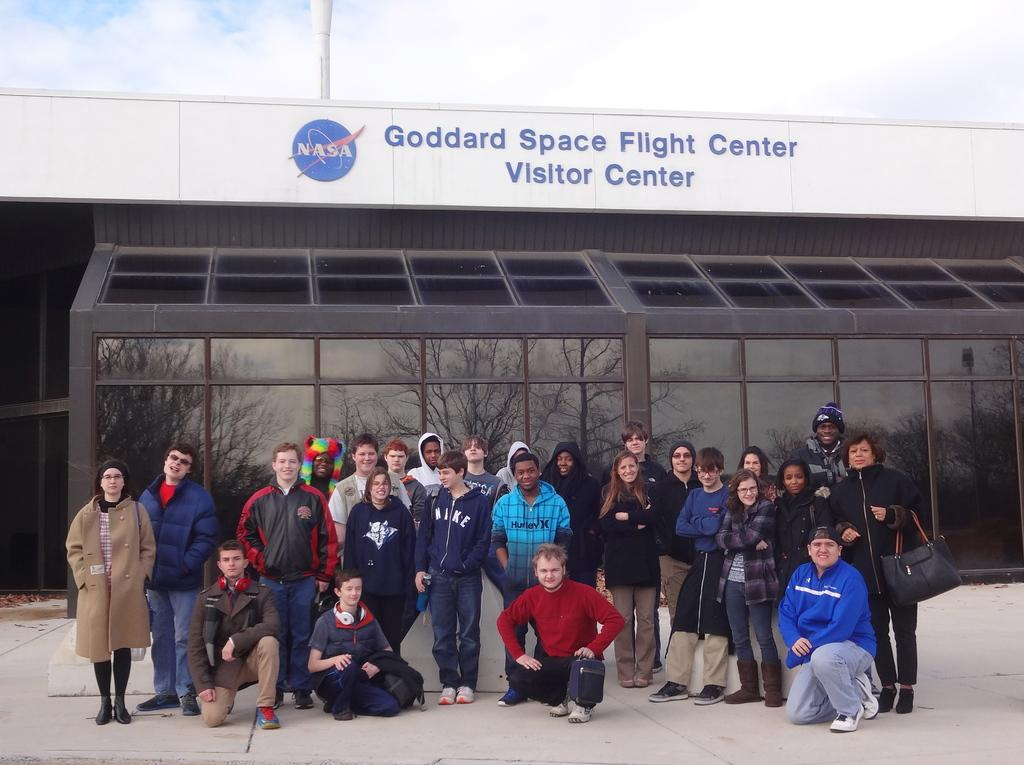What are the people in the image doing? The persons in the image are standing on the road. What can be seen in the background of the image? There are buildings in the background. What is visible at the top of the image? The sky is visible at the top of the image. What type of railway can be seen in the image? There is no railway present in the image; it only shows persons standing on the road and buildings in the background. 